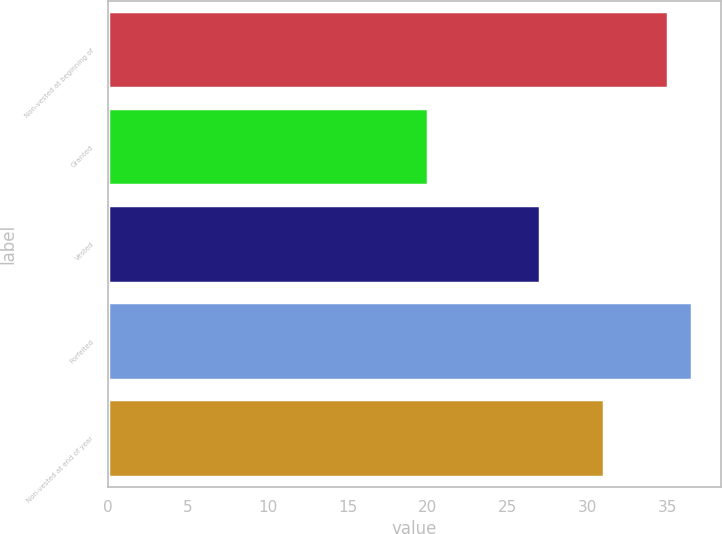Convert chart to OTSL. <chart><loc_0><loc_0><loc_500><loc_500><bar_chart><fcel>Non-vested at beginning of<fcel>Granted<fcel>Vested<fcel>Forfeited<fcel>Non-vested at end of year<nl><fcel>35<fcel>20<fcel>27<fcel>36.5<fcel>31<nl></chart> 